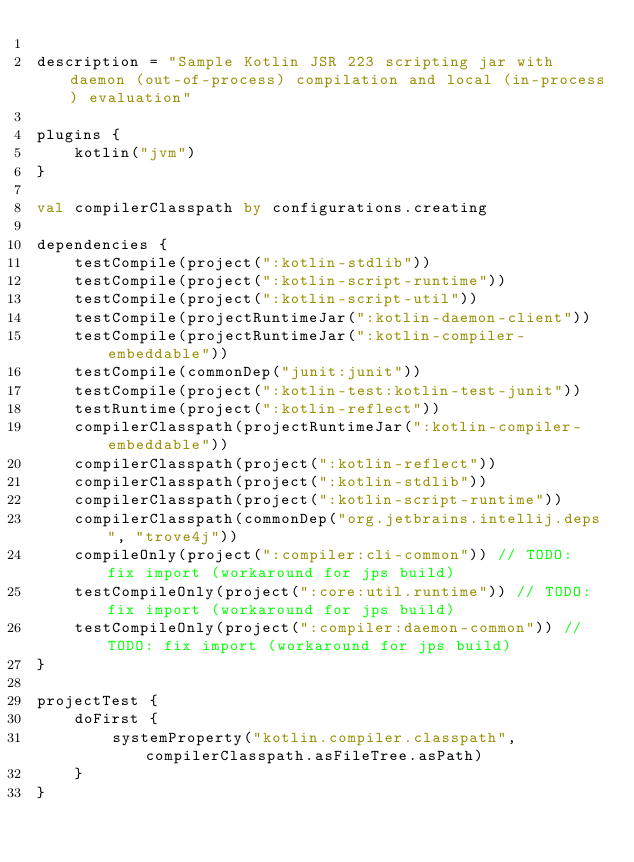<code> <loc_0><loc_0><loc_500><loc_500><_Kotlin_>
description = "Sample Kotlin JSR 223 scripting jar with daemon (out-of-process) compilation and local (in-process) evaluation"

plugins {
    kotlin("jvm")
}

val compilerClasspath by configurations.creating

dependencies {
    testCompile(project(":kotlin-stdlib"))
    testCompile(project(":kotlin-script-runtime"))
    testCompile(project(":kotlin-script-util"))
    testCompile(projectRuntimeJar(":kotlin-daemon-client"))
    testCompile(projectRuntimeJar(":kotlin-compiler-embeddable"))
    testCompile(commonDep("junit:junit"))
    testCompile(project(":kotlin-test:kotlin-test-junit"))
    testRuntime(project(":kotlin-reflect"))
    compilerClasspath(projectRuntimeJar(":kotlin-compiler-embeddable"))
    compilerClasspath(project(":kotlin-reflect"))
    compilerClasspath(project(":kotlin-stdlib"))
    compilerClasspath(project(":kotlin-script-runtime"))
    compilerClasspath(commonDep("org.jetbrains.intellij.deps", "trove4j"))
    compileOnly(project(":compiler:cli-common")) // TODO: fix import (workaround for jps build)
    testCompileOnly(project(":core:util.runtime")) // TODO: fix import (workaround for jps build)
    testCompileOnly(project(":compiler:daemon-common")) // TODO: fix import (workaround for jps build)
}

projectTest {
    doFirst {
        systemProperty("kotlin.compiler.classpath", compilerClasspath.asFileTree.asPath)
    }
}
</code> 